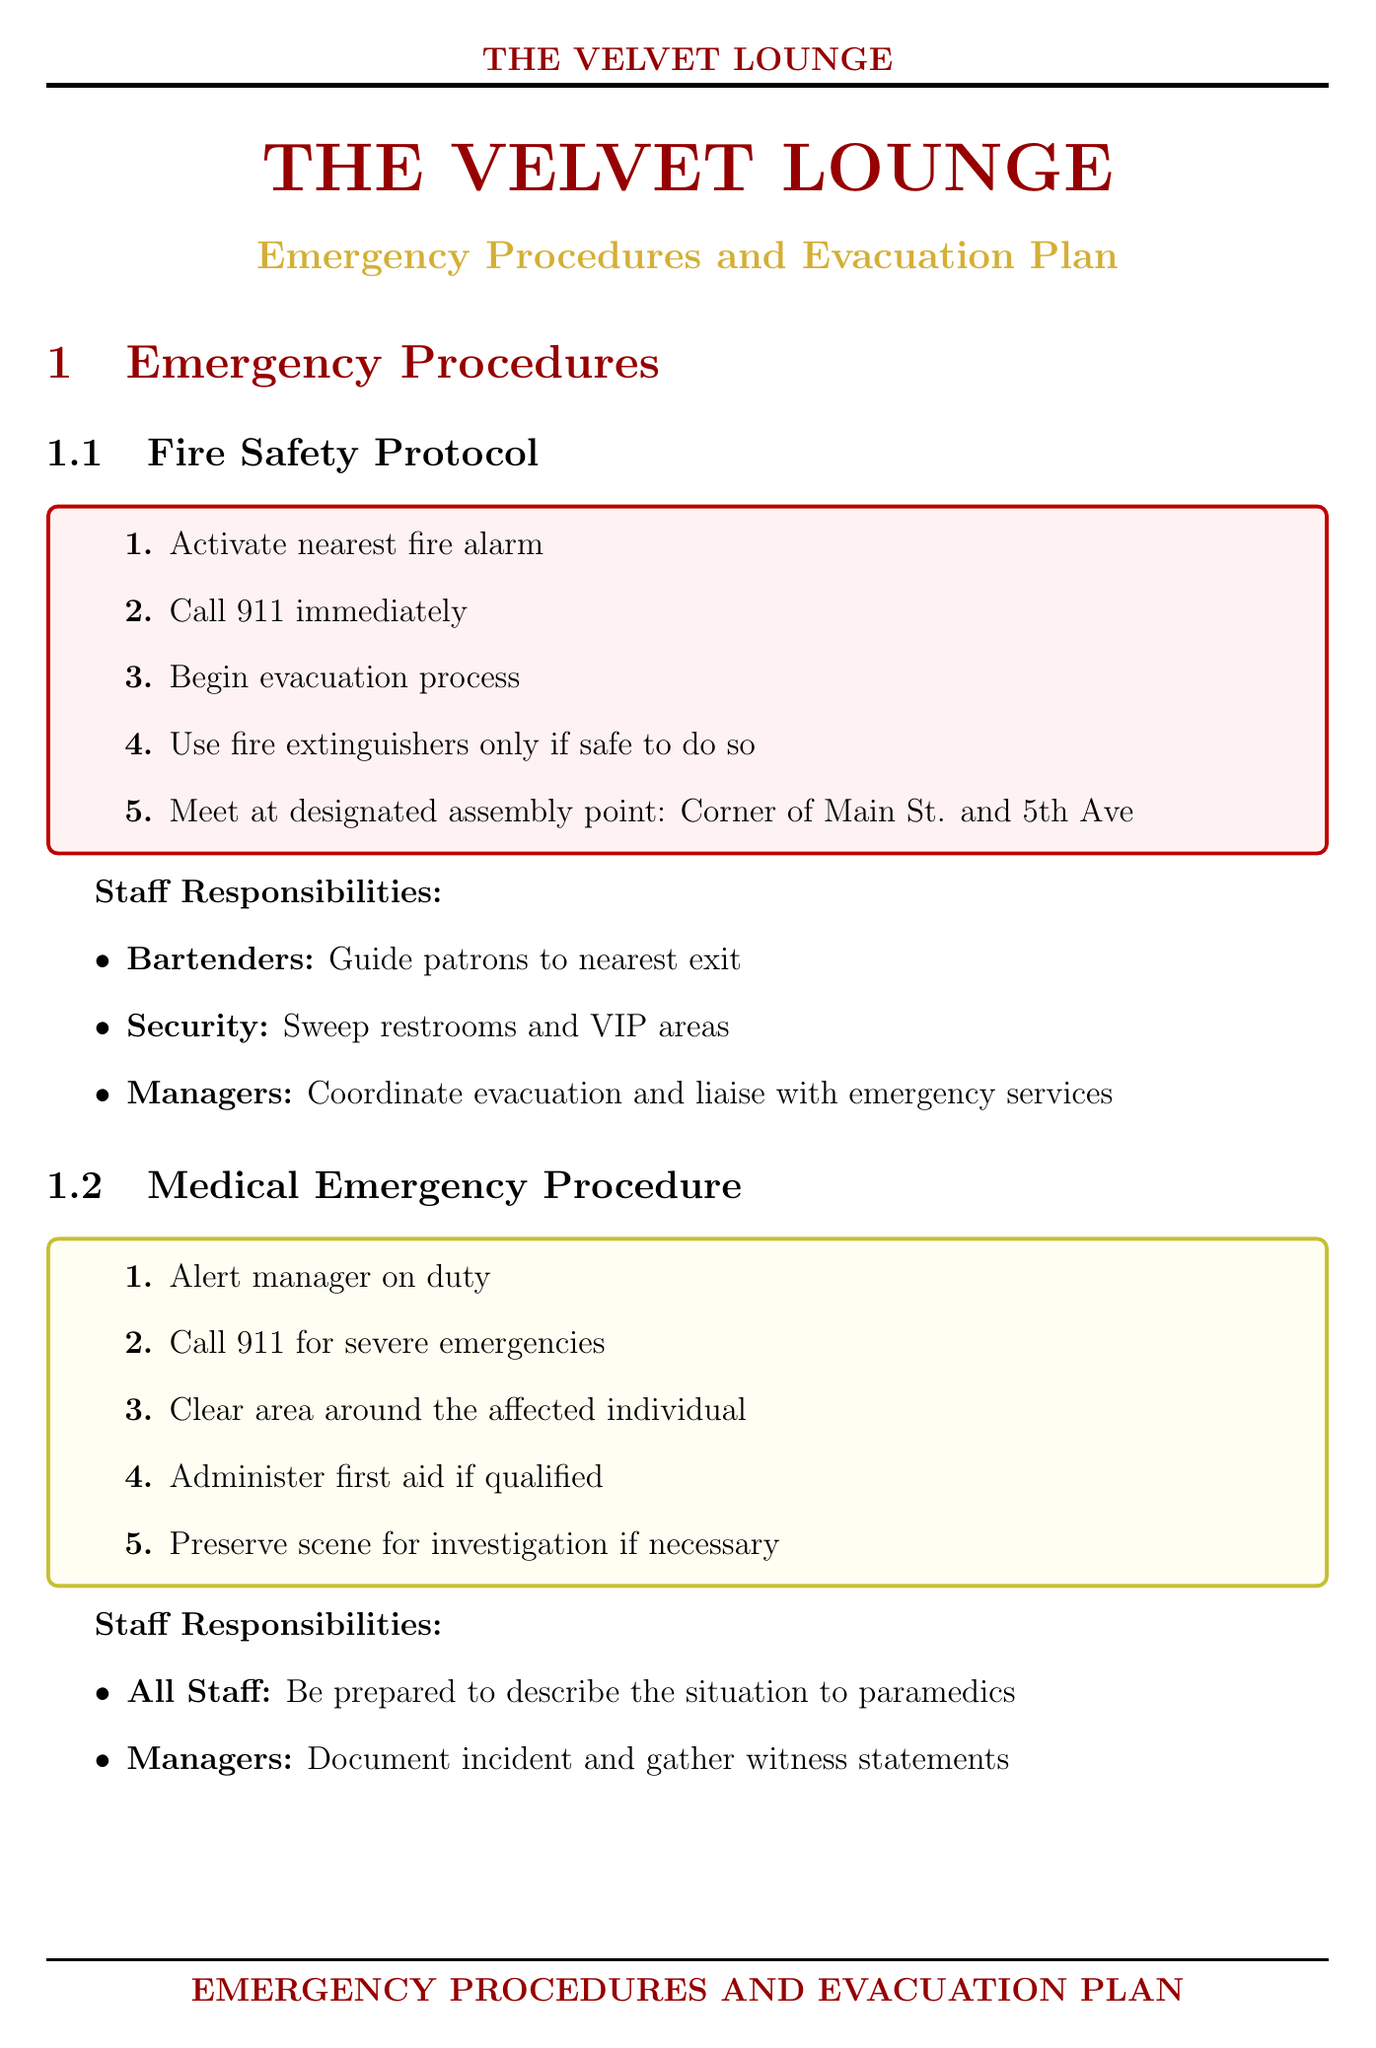what is the primary assembly point for evacuation? The primary assembly point is where patrons should gather after evacuation, mentioned in the evacuation plan.
Answer: Corner of Main St. and 5th Ave who is responsible for guiding patrons to the nearest exit during a fire? The document specifies the responsibilities of staff during emergencies, particularly in fire safety.
Answer: Bartenders how often is staff training conducted? This information pertains to the training schedule for staff as mentioned in the staff training section.
Answer: Quarterly what should staff do during a medical emergency? The steps that staff should follow in a medical emergency are clearly outlined under the medical emergency procedure.
Answer: Alert manager on duty what is the contact number for emergency services? This is a critical phone number listed for external communication during emergencies.
Answer: 911 how many persons is the capacity limit for the club? The capacity limit is listed under the legal compliance section of the document.
Answer: 500 persons which item is located next to the coat check? This information is about the location of emergency equipment mentioned in the emergency equipment section.
Answer: AED how will staff learn about severe weather alerts? Staff responsibilities regarding severe weather indicate how they stay informed during such events.
Answer: Monitor local weather alerts who maintains communication with local authorities during a severe weather event? The responsibility for authority communication is detailed in the severe weather protocol section.
Answer: Managers 